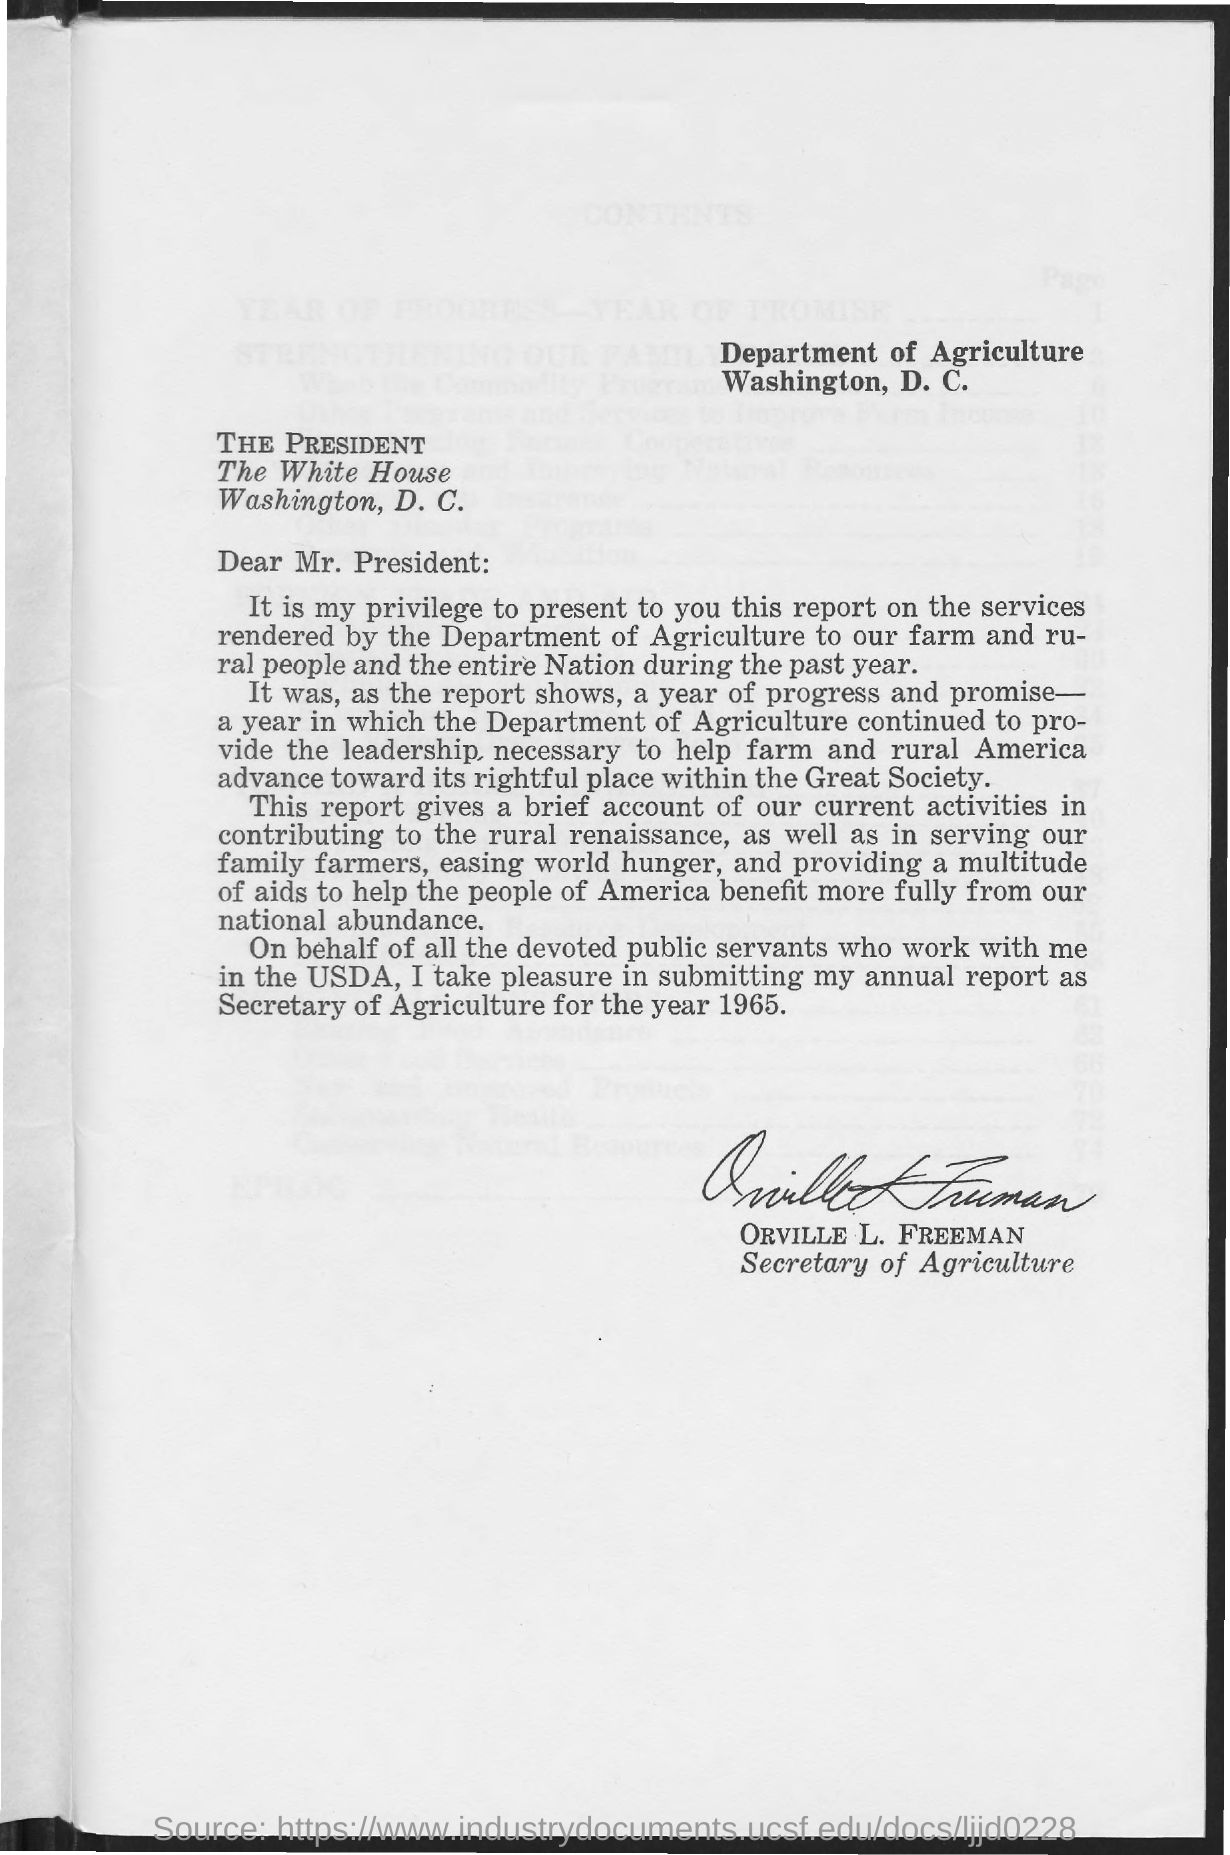Which department is mentioned in the letterhead?
Provide a succinct answer. Department of Agriculture. Who has signed this letter?
Provide a succinct answer. ORVILLE L. FREEMAN. What is the designation of ORVILLE L. FREEMAN?
Make the answer very short. Secretary of Agriculture. 